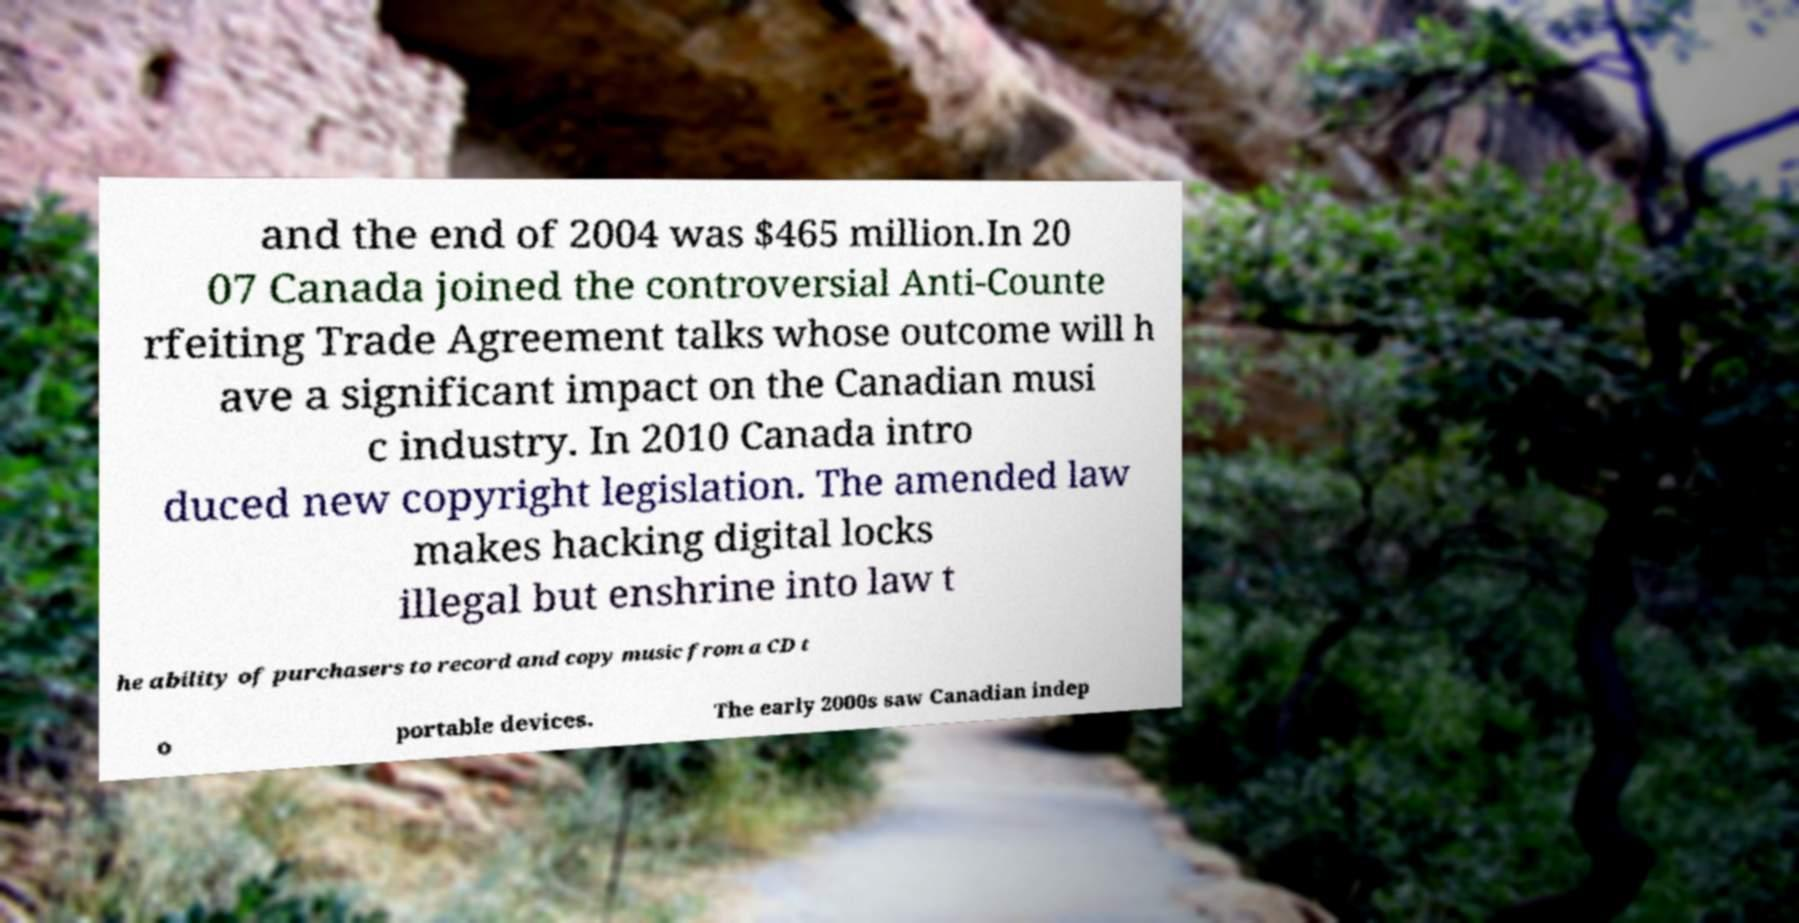Could you assist in decoding the text presented in this image and type it out clearly? and the end of 2004 was $465 million.In 20 07 Canada joined the controversial Anti-Counte rfeiting Trade Agreement talks whose outcome will h ave a significant impact on the Canadian musi c industry. In 2010 Canada intro duced new copyright legislation. The amended law makes hacking digital locks illegal but enshrine into law t he ability of purchasers to record and copy music from a CD t o portable devices. The early 2000s saw Canadian indep 